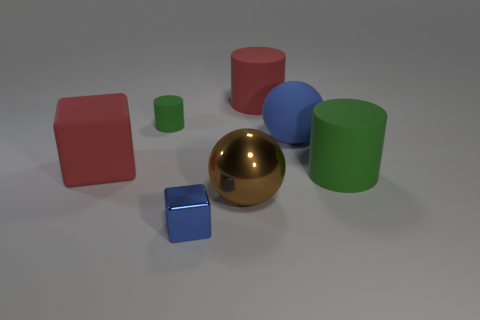What is the size of the blue thing that is the same shape as the big brown metallic object?
Make the answer very short. Large. What number of big yellow spheres have the same material as the blue cube?
Your answer should be compact. 0. How many objects are tiny blocks or red matte cylinders?
Provide a short and direct response. 2. Are there any big red things that are to the right of the red object that is behind the small green cylinder?
Ensure brevity in your answer.  No. Is the number of big brown metallic balls to the right of the red cylinder greater than the number of small blue things in front of the tiny block?
Offer a terse response. No. There is a cylinder that is the same color as the small rubber thing; what is its material?
Provide a succinct answer. Rubber. What number of big matte balls have the same color as the metal cube?
Ensure brevity in your answer.  1. There is a big matte cylinder that is behind the large green rubber object; is its color the same as the large object that is on the right side of the blue rubber object?
Ensure brevity in your answer.  No. There is a rubber block; are there any big brown metallic balls to the left of it?
Offer a very short reply. No. What is the tiny cube made of?
Provide a short and direct response. Metal. 